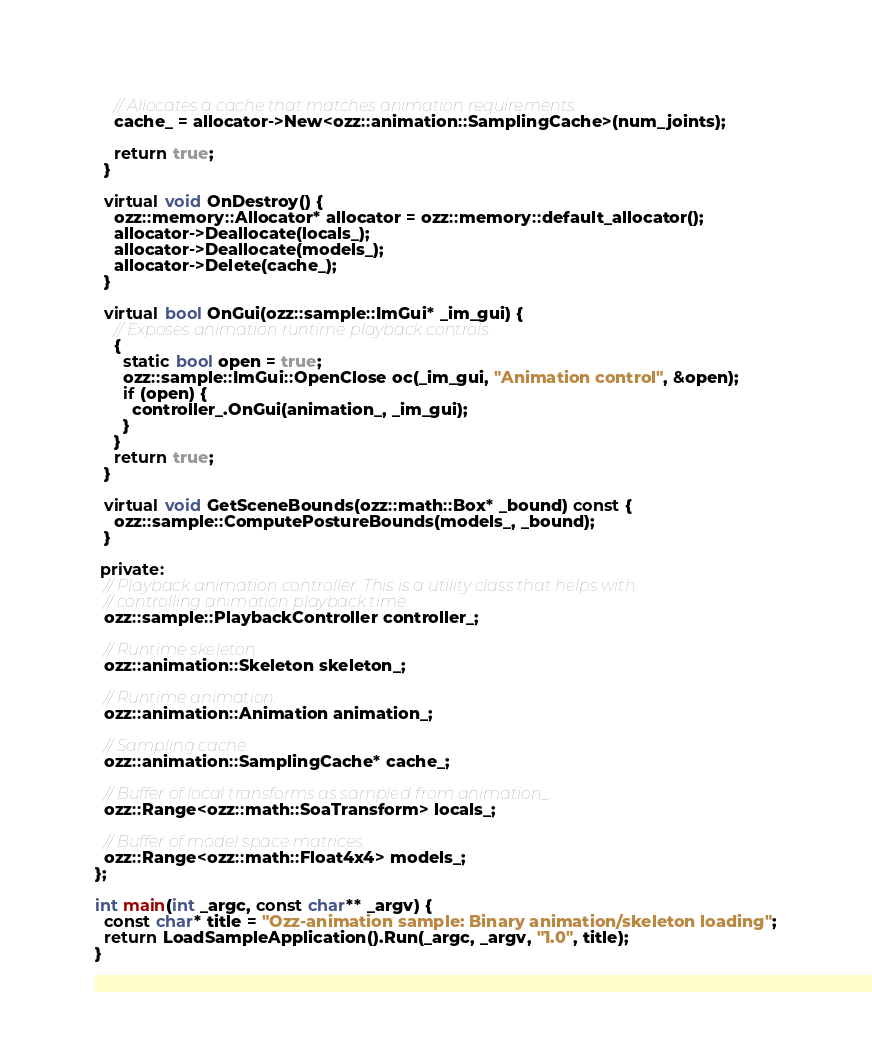Convert code to text. <code><loc_0><loc_0><loc_500><loc_500><_C++_>
    // Allocates a cache that matches animation requirements.
    cache_ = allocator->New<ozz::animation::SamplingCache>(num_joints);

    return true;
  }

  virtual void OnDestroy() {
    ozz::memory::Allocator* allocator = ozz::memory::default_allocator();
    allocator->Deallocate(locals_);
    allocator->Deallocate(models_);
    allocator->Delete(cache_);
  }

  virtual bool OnGui(ozz::sample::ImGui* _im_gui) {
    // Exposes animation runtime playback controls.
    {
      static bool open = true;
      ozz::sample::ImGui::OpenClose oc(_im_gui, "Animation control", &open);
      if (open) {
        controller_.OnGui(animation_, _im_gui);
      }
    }
    return true;
  }

  virtual void GetSceneBounds(ozz::math::Box* _bound) const {
    ozz::sample::ComputePostureBounds(models_, _bound);
  }

 private:
  // Playback animation controller. This is a utility class that helps with
  // controlling animation playback time.
  ozz::sample::PlaybackController controller_;

  // Runtime skeleton.
  ozz::animation::Skeleton skeleton_;

  // Runtime animation.
  ozz::animation::Animation animation_;

  // Sampling cache.
  ozz::animation::SamplingCache* cache_;

  // Buffer of local transforms as sampled from animation_.
  ozz::Range<ozz::math::SoaTransform> locals_;

  // Buffer of model space matrices.
  ozz::Range<ozz::math::Float4x4> models_;
};

int main(int _argc, const char** _argv) {
  const char* title = "Ozz-animation sample: Binary animation/skeleton loading";
  return LoadSampleApplication().Run(_argc, _argv, "1.0", title);
}
</code> 